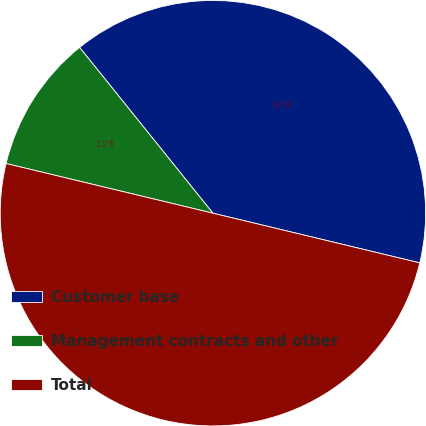<chart> <loc_0><loc_0><loc_500><loc_500><pie_chart><fcel>Customer base<fcel>Management contracts and other<fcel>Total<nl><fcel>39.53%<fcel>10.47%<fcel>50.0%<nl></chart> 